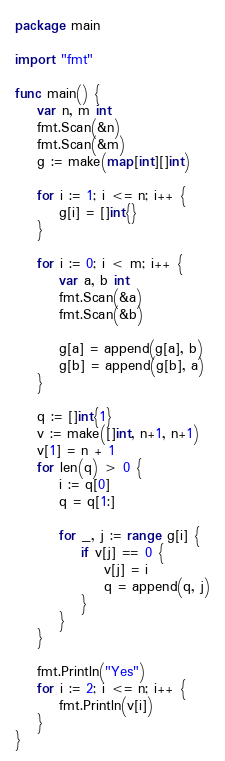<code> <loc_0><loc_0><loc_500><loc_500><_Go_>package main

import "fmt"

func main() {
	var n, m int
	fmt.Scan(&n)
	fmt.Scan(&m)
	g := make(map[int][]int)

	for i := 1; i <= n; i++ {
		g[i] = []int{}
	}

	for i := 0; i < m; i++ {
		var a, b int
		fmt.Scan(&a)
		fmt.Scan(&b)

		g[a] = append(g[a], b)
		g[b] = append(g[b], a)
	}

	q := []int{1}
	v := make([]int, n+1, n+1)
	v[1] = n + 1
	for len(q) > 0 {
		i := q[0]
		q = q[1:]

		for _, j := range g[i] {
			if v[j] == 0 {
				v[j] = i
				q = append(q, j)
			}
		}
	}

	fmt.Println("Yes")
	for i := 2; i <= n; i++ {
		fmt.Println(v[i])
	}
}
</code> 